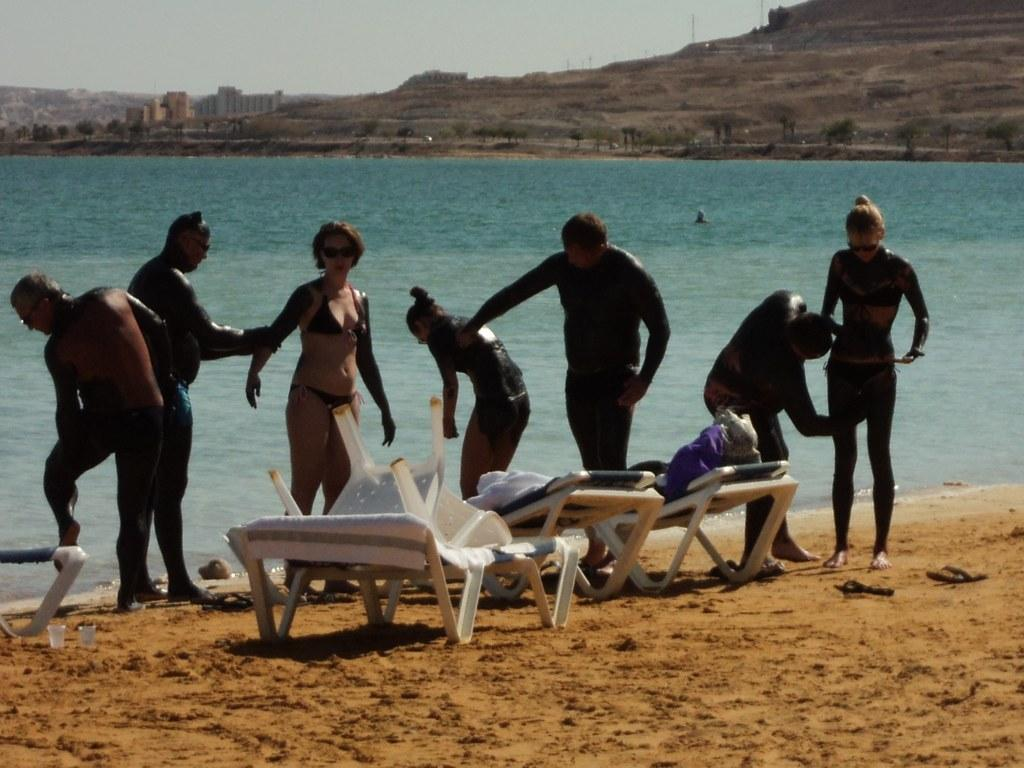Who or what can be seen in the foreground of the image? There are persons in the foreground of the image. Where are the persons located in relation to the beach? The persons are near a beach. What type of furniture is present on the ground in the image? There are chairs and beds on the ground. What can be seen in the background of the image? There is water, buildings, and the sky visible in the background. Can you tell me how many birds are flying over the coach in the image? There is no coach or birds present in the image. What type of bird can be seen interacting with the persons near the beach? There are no birds depicted interacting with the persons near the beach; only the persons, chairs, beds, water, buildings, and sky are present. 